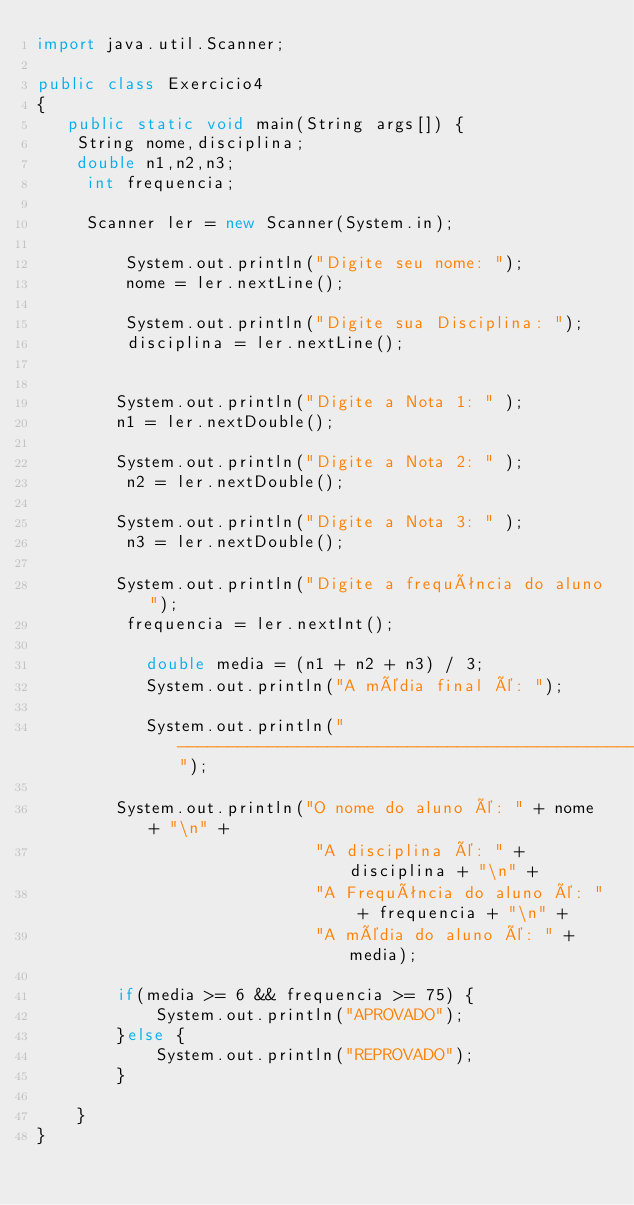Convert code to text. <code><loc_0><loc_0><loc_500><loc_500><_Java_>import java.util.Scanner;

public class Exercicio4
{
   public static void main(String args[]) {
    String nome,disciplina;
    double n1,n2,n3;
     int frequencia;
    
     Scanner ler = new Scanner(System.in);
    
         System.out.println("Digite seu nome: ");
         nome = ler.nextLine();
        
         System.out.println("Digite sua Disciplina: ");
         disciplina = ler.nextLine();
        
        
        System.out.println("Digite a Nota 1: " );
        n1 = ler.nextDouble();
       
        System.out.println("Digite a Nota 2: " );
         n2 = ler.nextDouble();
       
        System.out.println("Digite a Nota 3: " );
         n3 = ler.nextDouble();
        
        System.out.println("Digite a frequência do aluno");
         frequencia = ler.nextInt();
         
           double media = (n1 + n2 + n3) / 3;
           System.out.println("A média final é: ");
           
           System.out.println("--------------------------------------------------------");

        System.out.println("O nome do aluno é: " + nome + "\n" + 
                            "A disciplina é: " + disciplina + "\n" +
                            "A Frequência do aluno é: " + frequencia + "\n" + 
                            "A média do aluno é: " + media);
        
        if(media >= 6 && frequencia >= 75) {
            System.out.println("APROVADO");
        }else {
            System.out.println("REPROVADO");
        }   
        
    }
}
</code> 